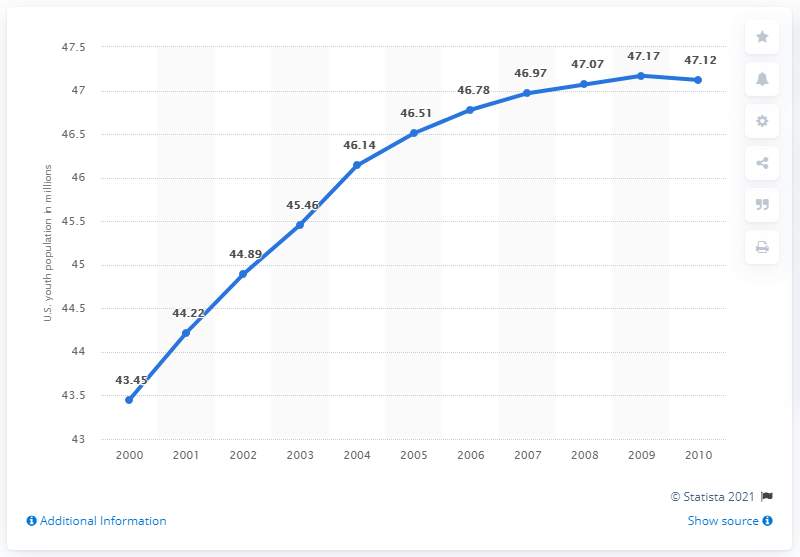How many young people lived in the U.S. between the ages of 14 and 24 in 2010? In 2010, the population of young people in the U.S. between the ages of 14 and 24 was approximately 47.12 million, according to the dataset presented in the image. 